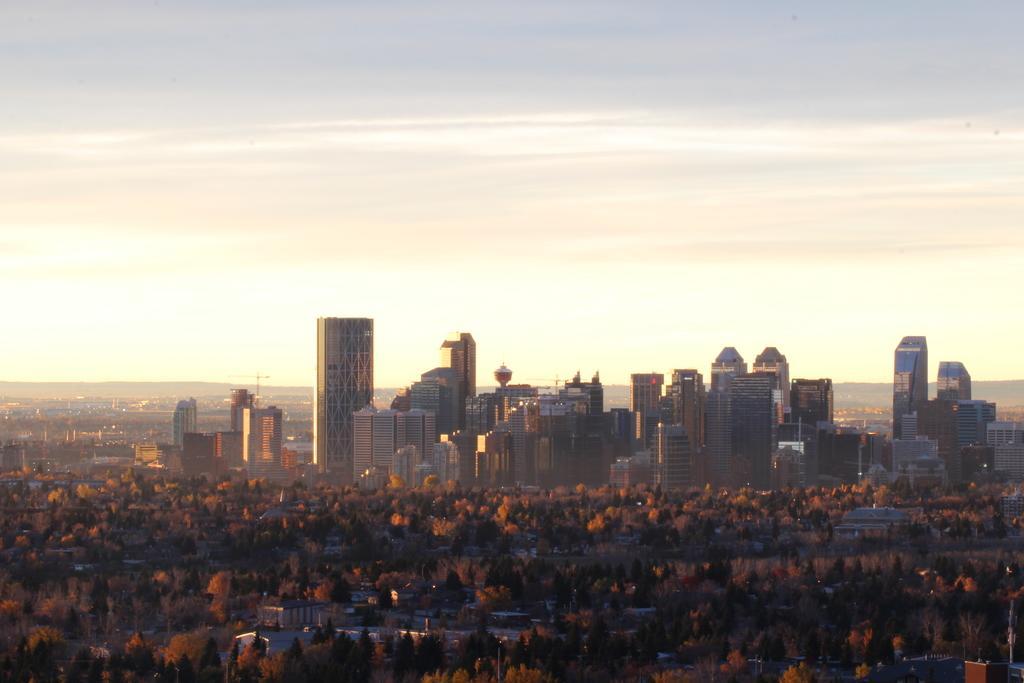Could you give a brief overview of what you see in this image? In this picture we can observe buildings. There are trees. In the background there is a sky. 